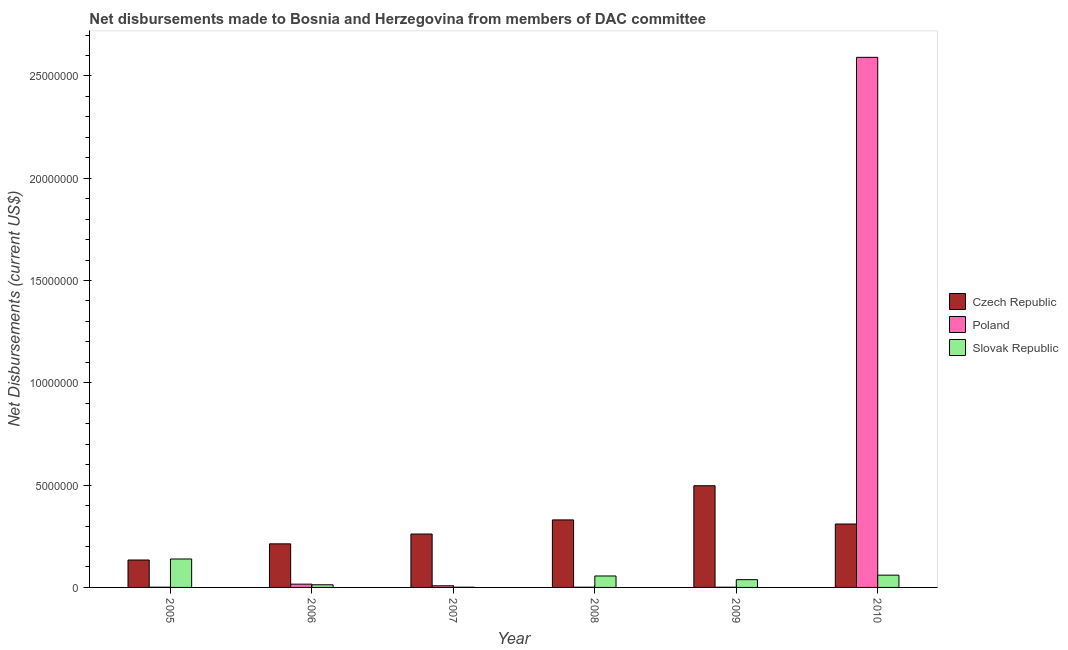How many different coloured bars are there?
Offer a very short reply. 3. Are the number of bars per tick equal to the number of legend labels?
Offer a terse response. Yes. Are the number of bars on each tick of the X-axis equal?
Offer a terse response. Yes. In how many cases, is the number of bars for a given year not equal to the number of legend labels?
Offer a terse response. 0. What is the net disbursements made by czech republic in 2009?
Keep it short and to the point. 4.97e+06. Across all years, what is the maximum net disbursements made by slovak republic?
Your answer should be very brief. 1.39e+06. Across all years, what is the minimum net disbursements made by poland?
Offer a terse response. 10000. In which year was the net disbursements made by poland maximum?
Your answer should be compact. 2010. What is the total net disbursements made by slovak republic in the graph?
Your answer should be compact. 3.07e+06. What is the difference between the net disbursements made by poland in 2005 and that in 2007?
Provide a succinct answer. -7.00e+04. What is the difference between the net disbursements made by slovak republic in 2007 and the net disbursements made by poland in 2009?
Offer a very short reply. -3.70e+05. What is the average net disbursements made by czech republic per year?
Provide a short and direct response. 2.91e+06. In the year 2008, what is the difference between the net disbursements made by poland and net disbursements made by czech republic?
Your answer should be compact. 0. What is the ratio of the net disbursements made by slovak republic in 2005 to that in 2006?
Ensure brevity in your answer.  10.69. What is the difference between the highest and the second highest net disbursements made by poland?
Make the answer very short. 2.58e+07. What is the difference between the highest and the lowest net disbursements made by czech republic?
Your answer should be compact. 3.63e+06. Is the sum of the net disbursements made by slovak republic in 2009 and 2010 greater than the maximum net disbursements made by poland across all years?
Offer a very short reply. No. What does the 3rd bar from the left in 2008 represents?
Your response must be concise. Slovak Republic. What does the 1st bar from the right in 2009 represents?
Ensure brevity in your answer.  Slovak Republic. Is it the case that in every year, the sum of the net disbursements made by czech republic and net disbursements made by poland is greater than the net disbursements made by slovak republic?
Ensure brevity in your answer.  No. How many bars are there?
Ensure brevity in your answer.  18. How many years are there in the graph?
Provide a short and direct response. 6. Are the values on the major ticks of Y-axis written in scientific E-notation?
Give a very brief answer. No. Does the graph contain any zero values?
Keep it short and to the point. No. Does the graph contain grids?
Your answer should be very brief. No. Where does the legend appear in the graph?
Provide a succinct answer. Center right. How many legend labels are there?
Provide a succinct answer. 3. What is the title of the graph?
Keep it short and to the point. Net disbursements made to Bosnia and Herzegovina from members of DAC committee. What is the label or title of the X-axis?
Ensure brevity in your answer.  Year. What is the label or title of the Y-axis?
Your answer should be very brief. Net Disbursements (current US$). What is the Net Disbursements (current US$) of Czech Republic in 2005?
Your answer should be very brief. 1.34e+06. What is the Net Disbursements (current US$) of Slovak Republic in 2005?
Provide a succinct answer. 1.39e+06. What is the Net Disbursements (current US$) of Czech Republic in 2006?
Offer a very short reply. 2.13e+06. What is the Net Disbursements (current US$) of Czech Republic in 2007?
Give a very brief answer. 2.61e+06. What is the Net Disbursements (current US$) of Poland in 2007?
Make the answer very short. 8.00e+04. What is the Net Disbursements (current US$) of Slovak Republic in 2007?
Offer a terse response. 10000. What is the Net Disbursements (current US$) of Czech Republic in 2008?
Offer a terse response. 3.30e+06. What is the Net Disbursements (current US$) in Poland in 2008?
Give a very brief answer. 10000. What is the Net Disbursements (current US$) in Slovak Republic in 2008?
Provide a succinct answer. 5.60e+05. What is the Net Disbursements (current US$) of Czech Republic in 2009?
Your answer should be compact. 4.97e+06. What is the Net Disbursements (current US$) of Poland in 2009?
Your answer should be very brief. 10000. What is the Net Disbursements (current US$) in Slovak Republic in 2009?
Ensure brevity in your answer.  3.80e+05. What is the Net Disbursements (current US$) of Czech Republic in 2010?
Ensure brevity in your answer.  3.10e+06. What is the Net Disbursements (current US$) of Poland in 2010?
Give a very brief answer. 2.59e+07. Across all years, what is the maximum Net Disbursements (current US$) of Czech Republic?
Keep it short and to the point. 4.97e+06. Across all years, what is the maximum Net Disbursements (current US$) of Poland?
Your response must be concise. 2.59e+07. Across all years, what is the maximum Net Disbursements (current US$) in Slovak Republic?
Make the answer very short. 1.39e+06. Across all years, what is the minimum Net Disbursements (current US$) of Czech Republic?
Your answer should be very brief. 1.34e+06. Across all years, what is the minimum Net Disbursements (current US$) in Slovak Republic?
Your answer should be very brief. 10000. What is the total Net Disbursements (current US$) in Czech Republic in the graph?
Provide a short and direct response. 1.74e+07. What is the total Net Disbursements (current US$) in Poland in the graph?
Your answer should be very brief. 2.62e+07. What is the total Net Disbursements (current US$) in Slovak Republic in the graph?
Your answer should be compact. 3.07e+06. What is the difference between the Net Disbursements (current US$) in Czech Republic in 2005 and that in 2006?
Keep it short and to the point. -7.90e+05. What is the difference between the Net Disbursements (current US$) in Poland in 2005 and that in 2006?
Your answer should be compact. -1.50e+05. What is the difference between the Net Disbursements (current US$) in Slovak Republic in 2005 and that in 2006?
Provide a short and direct response. 1.26e+06. What is the difference between the Net Disbursements (current US$) of Czech Republic in 2005 and that in 2007?
Provide a succinct answer. -1.27e+06. What is the difference between the Net Disbursements (current US$) of Poland in 2005 and that in 2007?
Offer a terse response. -7.00e+04. What is the difference between the Net Disbursements (current US$) in Slovak Republic in 2005 and that in 2007?
Make the answer very short. 1.38e+06. What is the difference between the Net Disbursements (current US$) of Czech Republic in 2005 and that in 2008?
Provide a succinct answer. -1.96e+06. What is the difference between the Net Disbursements (current US$) of Poland in 2005 and that in 2008?
Offer a terse response. 0. What is the difference between the Net Disbursements (current US$) in Slovak Republic in 2005 and that in 2008?
Give a very brief answer. 8.30e+05. What is the difference between the Net Disbursements (current US$) in Czech Republic in 2005 and that in 2009?
Your answer should be compact. -3.63e+06. What is the difference between the Net Disbursements (current US$) in Poland in 2005 and that in 2009?
Your response must be concise. 0. What is the difference between the Net Disbursements (current US$) in Slovak Republic in 2005 and that in 2009?
Offer a terse response. 1.01e+06. What is the difference between the Net Disbursements (current US$) in Czech Republic in 2005 and that in 2010?
Your response must be concise. -1.76e+06. What is the difference between the Net Disbursements (current US$) of Poland in 2005 and that in 2010?
Give a very brief answer. -2.59e+07. What is the difference between the Net Disbursements (current US$) in Slovak Republic in 2005 and that in 2010?
Ensure brevity in your answer.  7.90e+05. What is the difference between the Net Disbursements (current US$) in Czech Republic in 2006 and that in 2007?
Ensure brevity in your answer.  -4.80e+05. What is the difference between the Net Disbursements (current US$) of Czech Republic in 2006 and that in 2008?
Provide a succinct answer. -1.17e+06. What is the difference between the Net Disbursements (current US$) of Poland in 2006 and that in 2008?
Provide a short and direct response. 1.50e+05. What is the difference between the Net Disbursements (current US$) of Slovak Republic in 2006 and that in 2008?
Ensure brevity in your answer.  -4.30e+05. What is the difference between the Net Disbursements (current US$) in Czech Republic in 2006 and that in 2009?
Give a very brief answer. -2.84e+06. What is the difference between the Net Disbursements (current US$) in Poland in 2006 and that in 2009?
Give a very brief answer. 1.50e+05. What is the difference between the Net Disbursements (current US$) of Czech Republic in 2006 and that in 2010?
Keep it short and to the point. -9.70e+05. What is the difference between the Net Disbursements (current US$) in Poland in 2006 and that in 2010?
Your answer should be very brief. -2.58e+07. What is the difference between the Net Disbursements (current US$) in Slovak Republic in 2006 and that in 2010?
Your response must be concise. -4.70e+05. What is the difference between the Net Disbursements (current US$) of Czech Republic in 2007 and that in 2008?
Offer a terse response. -6.90e+05. What is the difference between the Net Disbursements (current US$) of Poland in 2007 and that in 2008?
Provide a short and direct response. 7.00e+04. What is the difference between the Net Disbursements (current US$) of Slovak Republic in 2007 and that in 2008?
Make the answer very short. -5.50e+05. What is the difference between the Net Disbursements (current US$) of Czech Republic in 2007 and that in 2009?
Your answer should be compact. -2.36e+06. What is the difference between the Net Disbursements (current US$) in Poland in 2007 and that in 2009?
Your response must be concise. 7.00e+04. What is the difference between the Net Disbursements (current US$) of Slovak Republic in 2007 and that in 2009?
Give a very brief answer. -3.70e+05. What is the difference between the Net Disbursements (current US$) of Czech Republic in 2007 and that in 2010?
Make the answer very short. -4.90e+05. What is the difference between the Net Disbursements (current US$) of Poland in 2007 and that in 2010?
Provide a short and direct response. -2.58e+07. What is the difference between the Net Disbursements (current US$) of Slovak Republic in 2007 and that in 2010?
Your answer should be very brief. -5.90e+05. What is the difference between the Net Disbursements (current US$) of Czech Republic in 2008 and that in 2009?
Give a very brief answer. -1.67e+06. What is the difference between the Net Disbursements (current US$) in Slovak Republic in 2008 and that in 2009?
Provide a succinct answer. 1.80e+05. What is the difference between the Net Disbursements (current US$) of Czech Republic in 2008 and that in 2010?
Your answer should be very brief. 2.00e+05. What is the difference between the Net Disbursements (current US$) of Poland in 2008 and that in 2010?
Give a very brief answer. -2.59e+07. What is the difference between the Net Disbursements (current US$) in Czech Republic in 2009 and that in 2010?
Offer a terse response. 1.87e+06. What is the difference between the Net Disbursements (current US$) of Poland in 2009 and that in 2010?
Your response must be concise. -2.59e+07. What is the difference between the Net Disbursements (current US$) of Czech Republic in 2005 and the Net Disbursements (current US$) of Poland in 2006?
Keep it short and to the point. 1.18e+06. What is the difference between the Net Disbursements (current US$) of Czech Republic in 2005 and the Net Disbursements (current US$) of Slovak Republic in 2006?
Ensure brevity in your answer.  1.21e+06. What is the difference between the Net Disbursements (current US$) of Czech Republic in 2005 and the Net Disbursements (current US$) of Poland in 2007?
Keep it short and to the point. 1.26e+06. What is the difference between the Net Disbursements (current US$) of Czech Republic in 2005 and the Net Disbursements (current US$) of Slovak Republic in 2007?
Make the answer very short. 1.33e+06. What is the difference between the Net Disbursements (current US$) in Poland in 2005 and the Net Disbursements (current US$) in Slovak Republic in 2007?
Keep it short and to the point. 0. What is the difference between the Net Disbursements (current US$) in Czech Republic in 2005 and the Net Disbursements (current US$) in Poland in 2008?
Offer a terse response. 1.33e+06. What is the difference between the Net Disbursements (current US$) in Czech Republic in 2005 and the Net Disbursements (current US$) in Slovak Republic in 2008?
Make the answer very short. 7.80e+05. What is the difference between the Net Disbursements (current US$) in Poland in 2005 and the Net Disbursements (current US$) in Slovak Republic in 2008?
Offer a terse response. -5.50e+05. What is the difference between the Net Disbursements (current US$) in Czech Republic in 2005 and the Net Disbursements (current US$) in Poland in 2009?
Give a very brief answer. 1.33e+06. What is the difference between the Net Disbursements (current US$) in Czech Republic in 2005 and the Net Disbursements (current US$) in Slovak Republic in 2009?
Your answer should be very brief. 9.60e+05. What is the difference between the Net Disbursements (current US$) of Poland in 2005 and the Net Disbursements (current US$) of Slovak Republic in 2009?
Keep it short and to the point. -3.70e+05. What is the difference between the Net Disbursements (current US$) of Czech Republic in 2005 and the Net Disbursements (current US$) of Poland in 2010?
Offer a very short reply. -2.46e+07. What is the difference between the Net Disbursements (current US$) in Czech Republic in 2005 and the Net Disbursements (current US$) in Slovak Republic in 2010?
Your response must be concise. 7.40e+05. What is the difference between the Net Disbursements (current US$) of Poland in 2005 and the Net Disbursements (current US$) of Slovak Republic in 2010?
Make the answer very short. -5.90e+05. What is the difference between the Net Disbursements (current US$) in Czech Republic in 2006 and the Net Disbursements (current US$) in Poland in 2007?
Ensure brevity in your answer.  2.05e+06. What is the difference between the Net Disbursements (current US$) of Czech Republic in 2006 and the Net Disbursements (current US$) of Slovak Republic in 2007?
Make the answer very short. 2.12e+06. What is the difference between the Net Disbursements (current US$) in Poland in 2006 and the Net Disbursements (current US$) in Slovak Republic in 2007?
Your answer should be compact. 1.50e+05. What is the difference between the Net Disbursements (current US$) of Czech Republic in 2006 and the Net Disbursements (current US$) of Poland in 2008?
Offer a terse response. 2.12e+06. What is the difference between the Net Disbursements (current US$) of Czech Republic in 2006 and the Net Disbursements (current US$) of Slovak Republic in 2008?
Ensure brevity in your answer.  1.57e+06. What is the difference between the Net Disbursements (current US$) of Poland in 2006 and the Net Disbursements (current US$) of Slovak Republic in 2008?
Offer a very short reply. -4.00e+05. What is the difference between the Net Disbursements (current US$) of Czech Republic in 2006 and the Net Disbursements (current US$) of Poland in 2009?
Offer a terse response. 2.12e+06. What is the difference between the Net Disbursements (current US$) of Czech Republic in 2006 and the Net Disbursements (current US$) of Slovak Republic in 2009?
Provide a succinct answer. 1.75e+06. What is the difference between the Net Disbursements (current US$) of Poland in 2006 and the Net Disbursements (current US$) of Slovak Republic in 2009?
Make the answer very short. -2.20e+05. What is the difference between the Net Disbursements (current US$) of Czech Republic in 2006 and the Net Disbursements (current US$) of Poland in 2010?
Your answer should be very brief. -2.38e+07. What is the difference between the Net Disbursements (current US$) in Czech Republic in 2006 and the Net Disbursements (current US$) in Slovak Republic in 2010?
Offer a terse response. 1.53e+06. What is the difference between the Net Disbursements (current US$) of Poland in 2006 and the Net Disbursements (current US$) of Slovak Republic in 2010?
Ensure brevity in your answer.  -4.40e+05. What is the difference between the Net Disbursements (current US$) in Czech Republic in 2007 and the Net Disbursements (current US$) in Poland in 2008?
Provide a short and direct response. 2.60e+06. What is the difference between the Net Disbursements (current US$) of Czech Republic in 2007 and the Net Disbursements (current US$) of Slovak Republic in 2008?
Your answer should be very brief. 2.05e+06. What is the difference between the Net Disbursements (current US$) of Poland in 2007 and the Net Disbursements (current US$) of Slovak Republic in 2008?
Make the answer very short. -4.80e+05. What is the difference between the Net Disbursements (current US$) of Czech Republic in 2007 and the Net Disbursements (current US$) of Poland in 2009?
Offer a terse response. 2.60e+06. What is the difference between the Net Disbursements (current US$) of Czech Republic in 2007 and the Net Disbursements (current US$) of Slovak Republic in 2009?
Your response must be concise. 2.23e+06. What is the difference between the Net Disbursements (current US$) of Czech Republic in 2007 and the Net Disbursements (current US$) of Poland in 2010?
Make the answer very short. -2.33e+07. What is the difference between the Net Disbursements (current US$) in Czech Republic in 2007 and the Net Disbursements (current US$) in Slovak Republic in 2010?
Provide a succinct answer. 2.01e+06. What is the difference between the Net Disbursements (current US$) in Poland in 2007 and the Net Disbursements (current US$) in Slovak Republic in 2010?
Ensure brevity in your answer.  -5.20e+05. What is the difference between the Net Disbursements (current US$) of Czech Republic in 2008 and the Net Disbursements (current US$) of Poland in 2009?
Keep it short and to the point. 3.29e+06. What is the difference between the Net Disbursements (current US$) in Czech Republic in 2008 and the Net Disbursements (current US$) in Slovak Republic in 2009?
Keep it short and to the point. 2.92e+06. What is the difference between the Net Disbursements (current US$) of Poland in 2008 and the Net Disbursements (current US$) of Slovak Republic in 2009?
Provide a short and direct response. -3.70e+05. What is the difference between the Net Disbursements (current US$) of Czech Republic in 2008 and the Net Disbursements (current US$) of Poland in 2010?
Make the answer very short. -2.26e+07. What is the difference between the Net Disbursements (current US$) in Czech Republic in 2008 and the Net Disbursements (current US$) in Slovak Republic in 2010?
Give a very brief answer. 2.70e+06. What is the difference between the Net Disbursements (current US$) of Poland in 2008 and the Net Disbursements (current US$) of Slovak Republic in 2010?
Offer a very short reply. -5.90e+05. What is the difference between the Net Disbursements (current US$) in Czech Republic in 2009 and the Net Disbursements (current US$) in Poland in 2010?
Your answer should be compact. -2.09e+07. What is the difference between the Net Disbursements (current US$) of Czech Republic in 2009 and the Net Disbursements (current US$) of Slovak Republic in 2010?
Make the answer very short. 4.37e+06. What is the difference between the Net Disbursements (current US$) of Poland in 2009 and the Net Disbursements (current US$) of Slovak Republic in 2010?
Keep it short and to the point. -5.90e+05. What is the average Net Disbursements (current US$) in Czech Republic per year?
Provide a short and direct response. 2.91e+06. What is the average Net Disbursements (current US$) in Poland per year?
Keep it short and to the point. 4.36e+06. What is the average Net Disbursements (current US$) in Slovak Republic per year?
Provide a succinct answer. 5.12e+05. In the year 2005, what is the difference between the Net Disbursements (current US$) in Czech Republic and Net Disbursements (current US$) in Poland?
Your answer should be very brief. 1.33e+06. In the year 2005, what is the difference between the Net Disbursements (current US$) in Poland and Net Disbursements (current US$) in Slovak Republic?
Give a very brief answer. -1.38e+06. In the year 2006, what is the difference between the Net Disbursements (current US$) in Czech Republic and Net Disbursements (current US$) in Poland?
Your response must be concise. 1.97e+06. In the year 2007, what is the difference between the Net Disbursements (current US$) in Czech Republic and Net Disbursements (current US$) in Poland?
Offer a terse response. 2.53e+06. In the year 2007, what is the difference between the Net Disbursements (current US$) in Czech Republic and Net Disbursements (current US$) in Slovak Republic?
Give a very brief answer. 2.60e+06. In the year 2007, what is the difference between the Net Disbursements (current US$) of Poland and Net Disbursements (current US$) of Slovak Republic?
Ensure brevity in your answer.  7.00e+04. In the year 2008, what is the difference between the Net Disbursements (current US$) of Czech Republic and Net Disbursements (current US$) of Poland?
Make the answer very short. 3.29e+06. In the year 2008, what is the difference between the Net Disbursements (current US$) in Czech Republic and Net Disbursements (current US$) in Slovak Republic?
Your response must be concise. 2.74e+06. In the year 2008, what is the difference between the Net Disbursements (current US$) in Poland and Net Disbursements (current US$) in Slovak Republic?
Provide a short and direct response. -5.50e+05. In the year 2009, what is the difference between the Net Disbursements (current US$) of Czech Republic and Net Disbursements (current US$) of Poland?
Keep it short and to the point. 4.96e+06. In the year 2009, what is the difference between the Net Disbursements (current US$) of Czech Republic and Net Disbursements (current US$) of Slovak Republic?
Provide a succinct answer. 4.59e+06. In the year 2009, what is the difference between the Net Disbursements (current US$) of Poland and Net Disbursements (current US$) of Slovak Republic?
Make the answer very short. -3.70e+05. In the year 2010, what is the difference between the Net Disbursements (current US$) in Czech Republic and Net Disbursements (current US$) in Poland?
Offer a terse response. -2.28e+07. In the year 2010, what is the difference between the Net Disbursements (current US$) in Czech Republic and Net Disbursements (current US$) in Slovak Republic?
Keep it short and to the point. 2.50e+06. In the year 2010, what is the difference between the Net Disbursements (current US$) of Poland and Net Disbursements (current US$) of Slovak Republic?
Keep it short and to the point. 2.53e+07. What is the ratio of the Net Disbursements (current US$) in Czech Republic in 2005 to that in 2006?
Offer a terse response. 0.63. What is the ratio of the Net Disbursements (current US$) in Poland in 2005 to that in 2006?
Provide a succinct answer. 0.06. What is the ratio of the Net Disbursements (current US$) of Slovak Republic in 2005 to that in 2006?
Your answer should be very brief. 10.69. What is the ratio of the Net Disbursements (current US$) of Czech Republic in 2005 to that in 2007?
Ensure brevity in your answer.  0.51. What is the ratio of the Net Disbursements (current US$) in Slovak Republic in 2005 to that in 2007?
Make the answer very short. 139. What is the ratio of the Net Disbursements (current US$) in Czech Republic in 2005 to that in 2008?
Offer a terse response. 0.41. What is the ratio of the Net Disbursements (current US$) of Poland in 2005 to that in 2008?
Ensure brevity in your answer.  1. What is the ratio of the Net Disbursements (current US$) of Slovak Republic in 2005 to that in 2008?
Give a very brief answer. 2.48. What is the ratio of the Net Disbursements (current US$) of Czech Republic in 2005 to that in 2009?
Your answer should be very brief. 0.27. What is the ratio of the Net Disbursements (current US$) in Slovak Republic in 2005 to that in 2009?
Your answer should be very brief. 3.66. What is the ratio of the Net Disbursements (current US$) of Czech Republic in 2005 to that in 2010?
Offer a terse response. 0.43. What is the ratio of the Net Disbursements (current US$) in Slovak Republic in 2005 to that in 2010?
Provide a short and direct response. 2.32. What is the ratio of the Net Disbursements (current US$) of Czech Republic in 2006 to that in 2007?
Give a very brief answer. 0.82. What is the ratio of the Net Disbursements (current US$) in Slovak Republic in 2006 to that in 2007?
Ensure brevity in your answer.  13. What is the ratio of the Net Disbursements (current US$) in Czech Republic in 2006 to that in 2008?
Make the answer very short. 0.65. What is the ratio of the Net Disbursements (current US$) of Slovak Republic in 2006 to that in 2008?
Your answer should be very brief. 0.23. What is the ratio of the Net Disbursements (current US$) of Czech Republic in 2006 to that in 2009?
Your answer should be very brief. 0.43. What is the ratio of the Net Disbursements (current US$) in Poland in 2006 to that in 2009?
Offer a terse response. 16. What is the ratio of the Net Disbursements (current US$) of Slovak Republic in 2006 to that in 2009?
Offer a very short reply. 0.34. What is the ratio of the Net Disbursements (current US$) in Czech Republic in 2006 to that in 2010?
Provide a short and direct response. 0.69. What is the ratio of the Net Disbursements (current US$) in Poland in 2006 to that in 2010?
Offer a terse response. 0.01. What is the ratio of the Net Disbursements (current US$) in Slovak Republic in 2006 to that in 2010?
Your response must be concise. 0.22. What is the ratio of the Net Disbursements (current US$) of Czech Republic in 2007 to that in 2008?
Provide a succinct answer. 0.79. What is the ratio of the Net Disbursements (current US$) of Poland in 2007 to that in 2008?
Offer a very short reply. 8. What is the ratio of the Net Disbursements (current US$) of Slovak Republic in 2007 to that in 2008?
Ensure brevity in your answer.  0.02. What is the ratio of the Net Disbursements (current US$) in Czech Republic in 2007 to that in 2009?
Offer a very short reply. 0.53. What is the ratio of the Net Disbursements (current US$) in Slovak Republic in 2007 to that in 2009?
Ensure brevity in your answer.  0.03. What is the ratio of the Net Disbursements (current US$) in Czech Republic in 2007 to that in 2010?
Keep it short and to the point. 0.84. What is the ratio of the Net Disbursements (current US$) in Poland in 2007 to that in 2010?
Your response must be concise. 0. What is the ratio of the Net Disbursements (current US$) in Slovak Republic in 2007 to that in 2010?
Offer a terse response. 0.02. What is the ratio of the Net Disbursements (current US$) of Czech Republic in 2008 to that in 2009?
Ensure brevity in your answer.  0.66. What is the ratio of the Net Disbursements (current US$) in Poland in 2008 to that in 2009?
Your answer should be compact. 1. What is the ratio of the Net Disbursements (current US$) in Slovak Republic in 2008 to that in 2009?
Offer a terse response. 1.47. What is the ratio of the Net Disbursements (current US$) of Czech Republic in 2008 to that in 2010?
Provide a short and direct response. 1.06. What is the ratio of the Net Disbursements (current US$) of Slovak Republic in 2008 to that in 2010?
Your answer should be very brief. 0.93. What is the ratio of the Net Disbursements (current US$) in Czech Republic in 2009 to that in 2010?
Ensure brevity in your answer.  1.6. What is the ratio of the Net Disbursements (current US$) of Slovak Republic in 2009 to that in 2010?
Your answer should be compact. 0.63. What is the difference between the highest and the second highest Net Disbursements (current US$) of Czech Republic?
Ensure brevity in your answer.  1.67e+06. What is the difference between the highest and the second highest Net Disbursements (current US$) of Poland?
Provide a succinct answer. 2.58e+07. What is the difference between the highest and the second highest Net Disbursements (current US$) of Slovak Republic?
Provide a short and direct response. 7.90e+05. What is the difference between the highest and the lowest Net Disbursements (current US$) in Czech Republic?
Your answer should be compact. 3.63e+06. What is the difference between the highest and the lowest Net Disbursements (current US$) in Poland?
Offer a very short reply. 2.59e+07. What is the difference between the highest and the lowest Net Disbursements (current US$) in Slovak Republic?
Ensure brevity in your answer.  1.38e+06. 